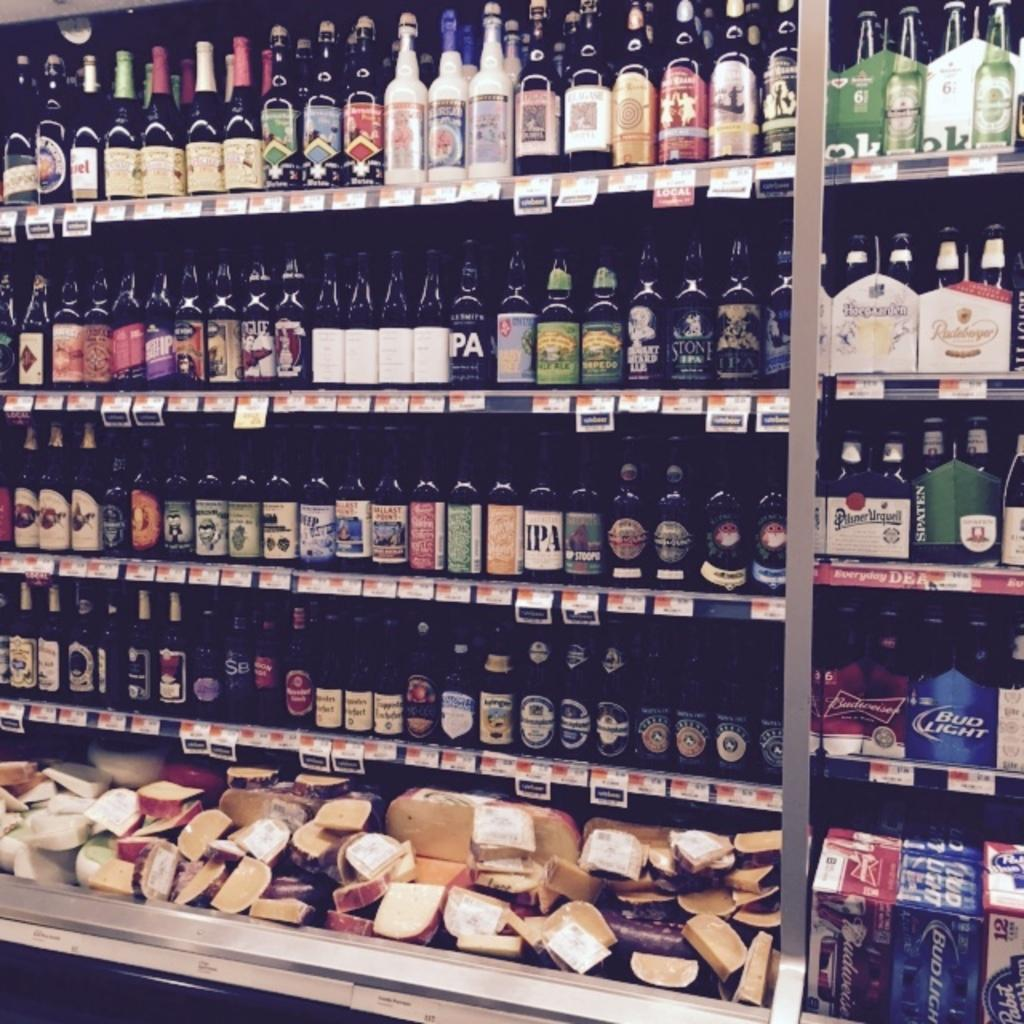<image>
Share a concise interpretation of the image provided. A bottle of IPA beer sits on a shelf among many different varieties of beer 